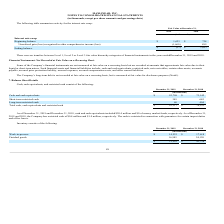From Maxlinear's financial document, What was the money market frauds in 2019 and 2018? The document shows two values: $20.4 million and $0. From the document: "ember 31, 2018, cash and cash equivalents included $20.4 million and $0 of money market funds, respectively. As of December 31, ember 31, 2018, cash a..." Also, In what respect is cash restricted? restricted in connection with guarantees for certain import duties and office leases.. The document states: "illion and $1.0 million, respectively. The cash is restricted in connection with guarantees for certain import duties and office leases...." Also, What was the Short-term restricted cash in 2019? According to the financial document, 349 (in thousands). The relevant text states: "Short-term restricted cash 349 645..." Also, can you calculate: What was the change in the cash and cash equivalents from 2018 to 2019? Based on the calculation: 92,708 - 73,142, the result is 19566 (in thousands). This is based on the information: "Cash and cash equivalents $ 92,708 $ 73,142 Cash and cash equivalents $ 92,708 $ 73,142..." The key data points involved are: 73,142, 92,708. Also, can you calculate: What is the average Short-term restricted cash for 2018 and 2019? To answer this question, I need to perform calculations using the financial data. The calculation is: (349 + 645) / 2, which equals 497 (in thousands). This is based on the information: "Short-term restricted cash 349 645 Short-term restricted cash 349 645..." The key data points involved are: 349, 645. Additionally, In which year was Long-term restricted cash less than 100 thousands? According to the financial document, 2019. The relevant text states: "December 31, 2019 December 31, 2018..." 